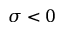Convert formula to latex. <formula><loc_0><loc_0><loc_500><loc_500>\sigma < 0</formula> 